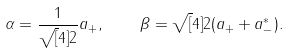<formula> <loc_0><loc_0><loc_500><loc_500>\alpha = \frac { 1 } { \sqrt { [ } 4 ] 2 } a _ { + } , \quad \beta = \sqrt { [ } 4 ] { 2 } ( a _ { + } + a _ { - } ^ { * } ) .</formula> 